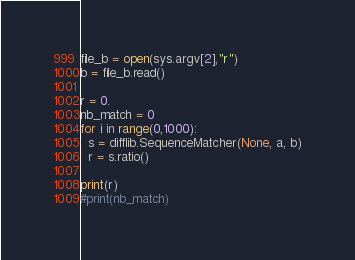<code> <loc_0><loc_0><loc_500><loc_500><_Python_>
file_b = open(sys.argv[2],"r")
b = file_b.read()

r = 0.
nb_match = 0
for i in range(0,1000):
  s = difflib.SequenceMatcher(None, a, b)
  r = s.ratio()

print(r) 
#print(nb_match)
</code> 